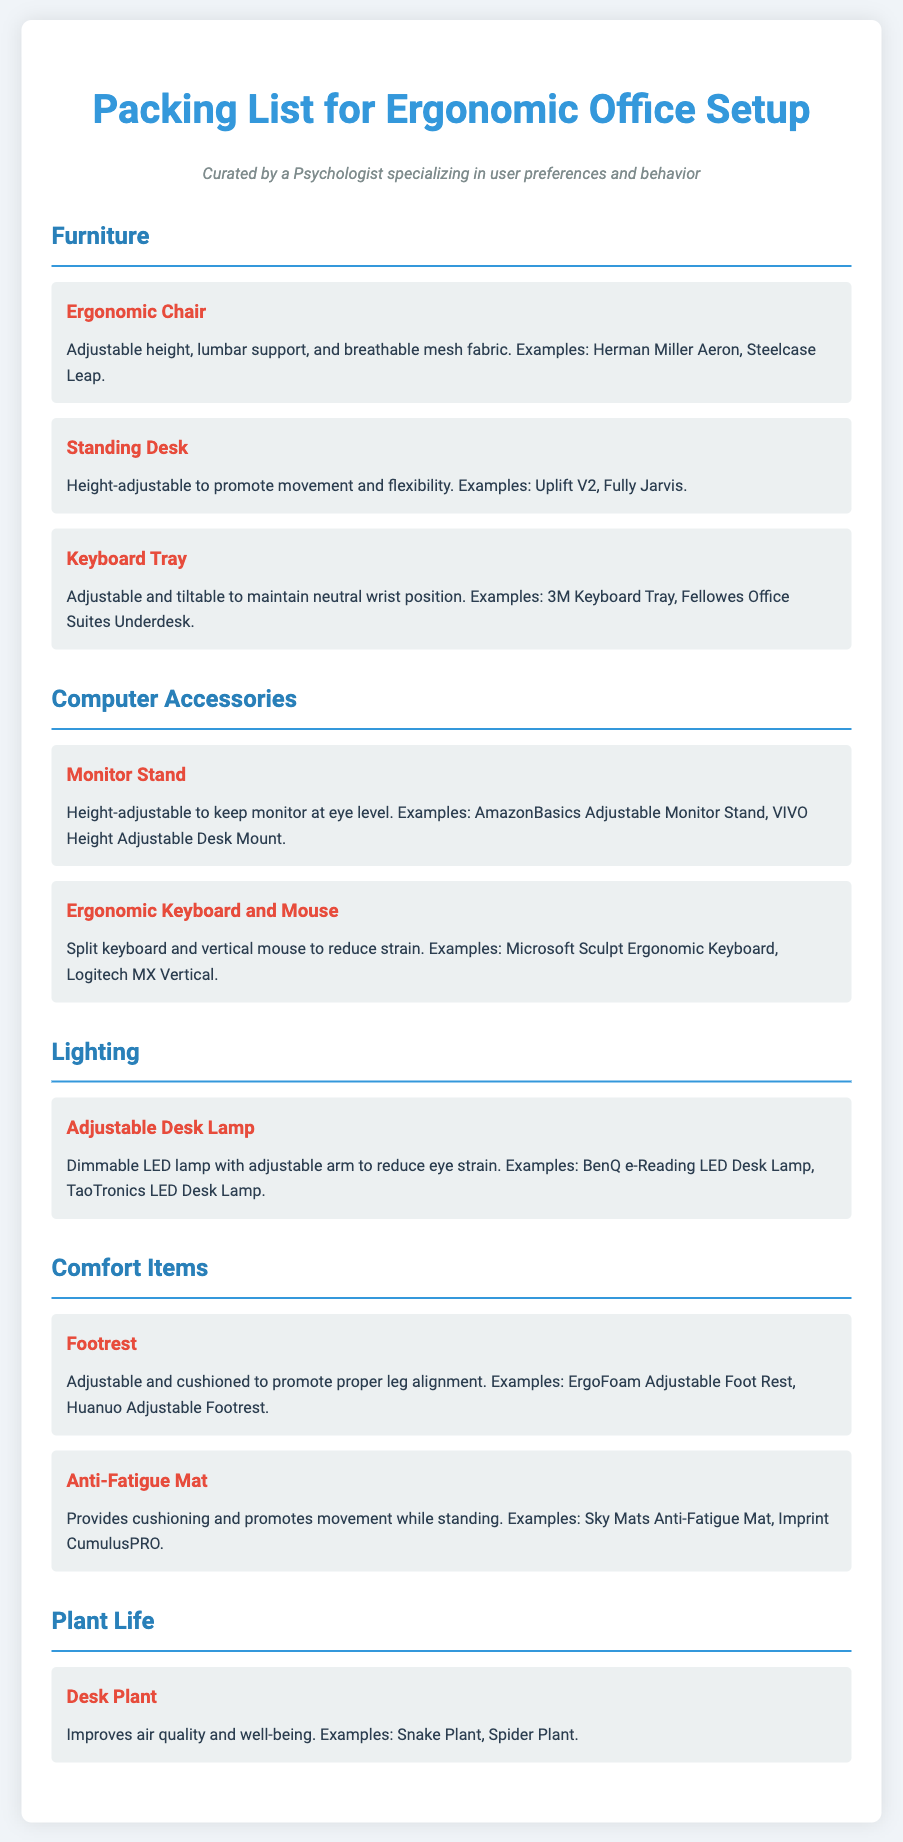What is the title of the document? The title of the document is prominently displayed at the top, indicating its purpose.
Answer: Packing List for Ergonomic Office Setup How many sections are in the document? The document contains five distinct sections, each focusing on a specific category of items.
Answer: 5 What is an example of an ergonomic chair mentioned? The document lists specific examples of ergonomic chairs under the furniture section.
Answer: Herman Miller Aeron What type of lamp is recommended for the ergonomic setup? The document specifies the type of lighting that is ideal for reducing eye strain.
Answer: Adjustable Desk Lamp What does the adjustable footrest promote? The document states the benefits of using an adjustable footrest in the comfort items section.
Answer: Proper leg alignment Which plant is suggested for improving air quality? The document provides examples of plants that can improve well-being and air quality.
Answer: Snake Plant What is the purpose of an anti-fatigue mat? The document describes the function of the anti-fatigue mat within the comfort items section.
Answer: Provides cushioning and promotes movement while standing What should a keyboard tray maintain? The document specifies the ergonomic benefit that a keyboard tray should provide in its description.
Answer: Neutral wrist position What color is the background of the document? The document design includes specific colors that contribute to its aesthetic.
Answer: Light blue 